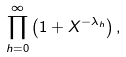Convert formula to latex. <formula><loc_0><loc_0><loc_500><loc_500>\prod _ { h = 0 } ^ { \infty } \left ( 1 + X ^ { - \lambda _ { h } } \right ) ,</formula> 